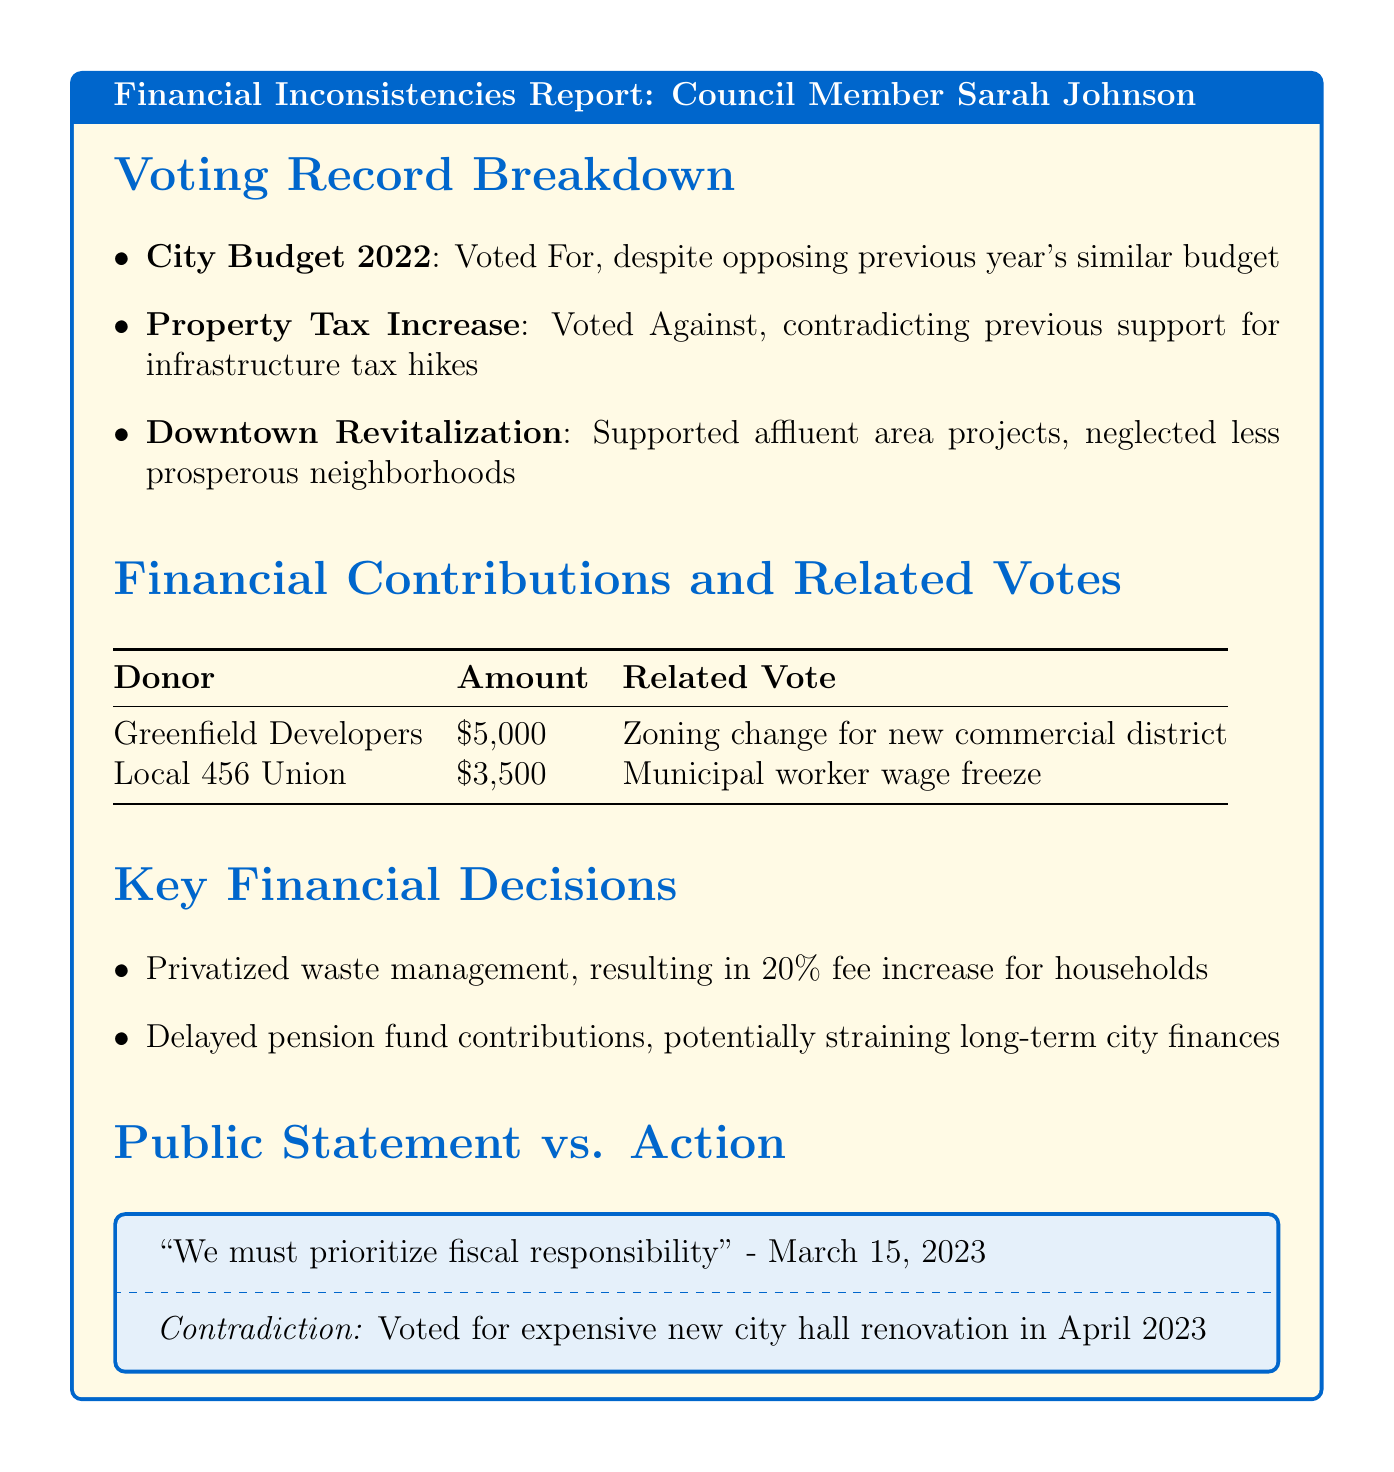What is the council member's name? The document explicitly states the name of the council member being discussed, which is Sarah Johnson.
Answer: Sarah Johnson How much did Greenfield Developers contribute? The financial contributions section lists the donor Greenfield Developers and their contribution amount.
Answer: $5,000 What was the vote on the City Budget 2022? The voting record breakdown section indicates how the council member voted on the City Budget 2022.
Answer: For What was the impact of privatizing waste management services? The key financial decisions section describes the impact of this decision on household waste collection fees.
Answer: 20% increase in household waste collection fees What contradiction is noted in the public statements? The document highlights a specific public statement and contrasts it with an action taken by the council member.
Answer: Voted for expensive new city hall renovation What issue did the council member vote against despite previous support? The voting record breakdown points out the issue on which the council member voted against something they previously supported.
Answer: Property Tax Increase How much did Local 456 Union contribute? The financial contributions section lists the donor Local 456 Union and their contribution amount.
Answer: $3,500 What issue did the council member support that involved less affluent neighborhoods? The voting record breakdown indicates the council member's support for a specific project and contrasts it with their voting pattern in less affluent neighborhoods.
Answer: Downtown Revitalization Fund 